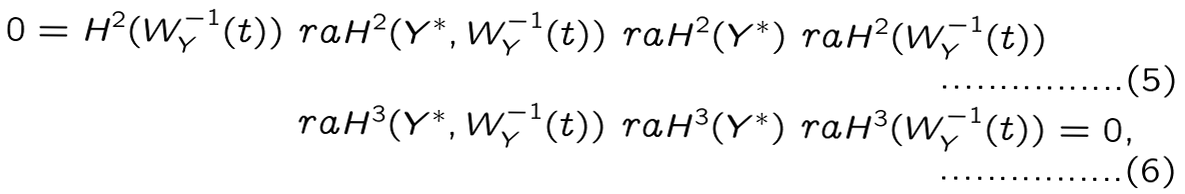<formula> <loc_0><loc_0><loc_500><loc_500>0 = H ^ { 2 } ( W _ { Y } ^ { - 1 } ( t ) ) \ r a H ^ { 2 } ( Y ^ { * } , W _ { Y } ^ { - 1 } ( t ) ) & \ r a H ^ { 2 } ( Y ^ { * } ) \ r a H ^ { 2 } ( W _ { Y } ^ { - 1 } ( t ) ) \\ \ r a H ^ { 3 } ( Y ^ { * } , W _ { Y } ^ { - 1 } ( t ) ) & \ r a H ^ { 3 } ( Y ^ { * } ) \ r a H ^ { 3 } ( W _ { Y } ^ { - 1 } ( t ) ) = 0 ,</formula> 